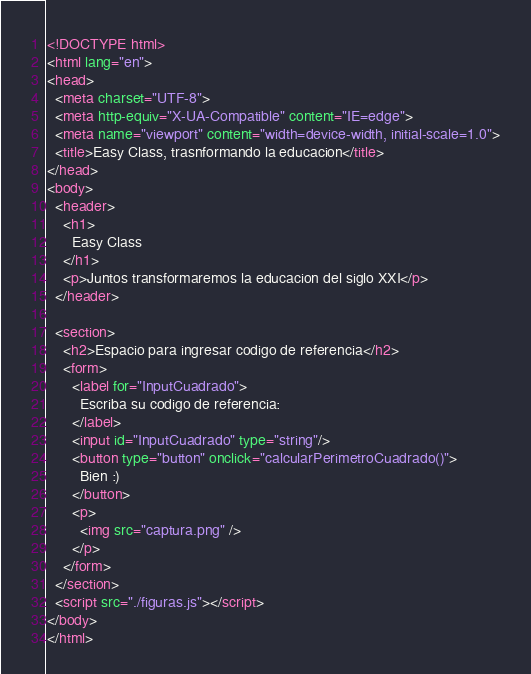Convert code to text. <code><loc_0><loc_0><loc_500><loc_500><_HTML_><!DOCTYPE html>
<html lang="en">
<head>
  <meta charset="UTF-8">
  <meta http-equiv="X-UA-Compatible" content="IE=edge">
  <meta name="viewport" content="width=device-width, initial-scale=1.0">
  <title>Easy Class, trasnformando la educacion</title>
</head>
<body>
  <header>
    <h1>
      Easy Class
    </h1>
    <p>Juntos transformaremos la educacion del siglo XXI</p>
  </header>

  <section>
    <h2>Espacio para ingresar codigo de referencia</h2>
    <form>
      <label for="InputCuadrado">
        Escriba su codigo de referencia:
      </label>
      <input id="InputCuadrado" type="string"/>
      <button type="button" onclick="calcularPerimetroCuadrado()">
        Bien :)
      </button>
      <p>
        <img src="captura.png" />
      </p>      
    </form>
  </section>
  <script src="./figuras.js"></script>
</body>
</html>
</code> 